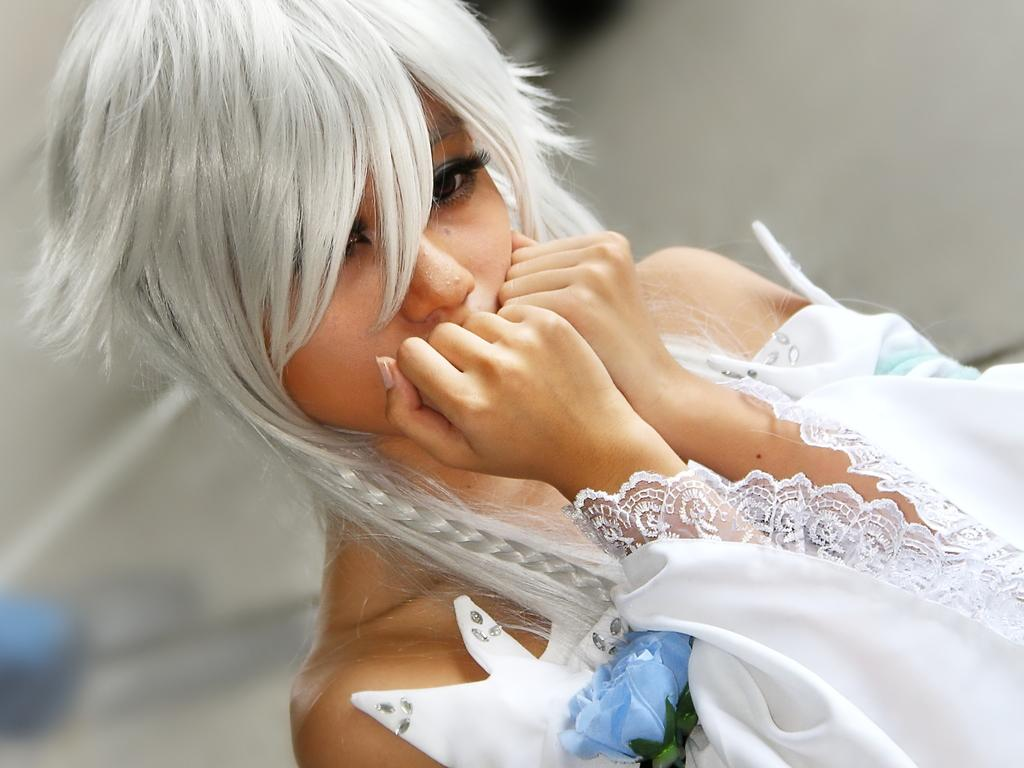What is the main subject of the image? There is a person in the image. Can you describe the background of the image? The background of the image is blurred. What type of yarn is the person using in the image? There is no yarn present in the image; it only features a person with a blurred background. 